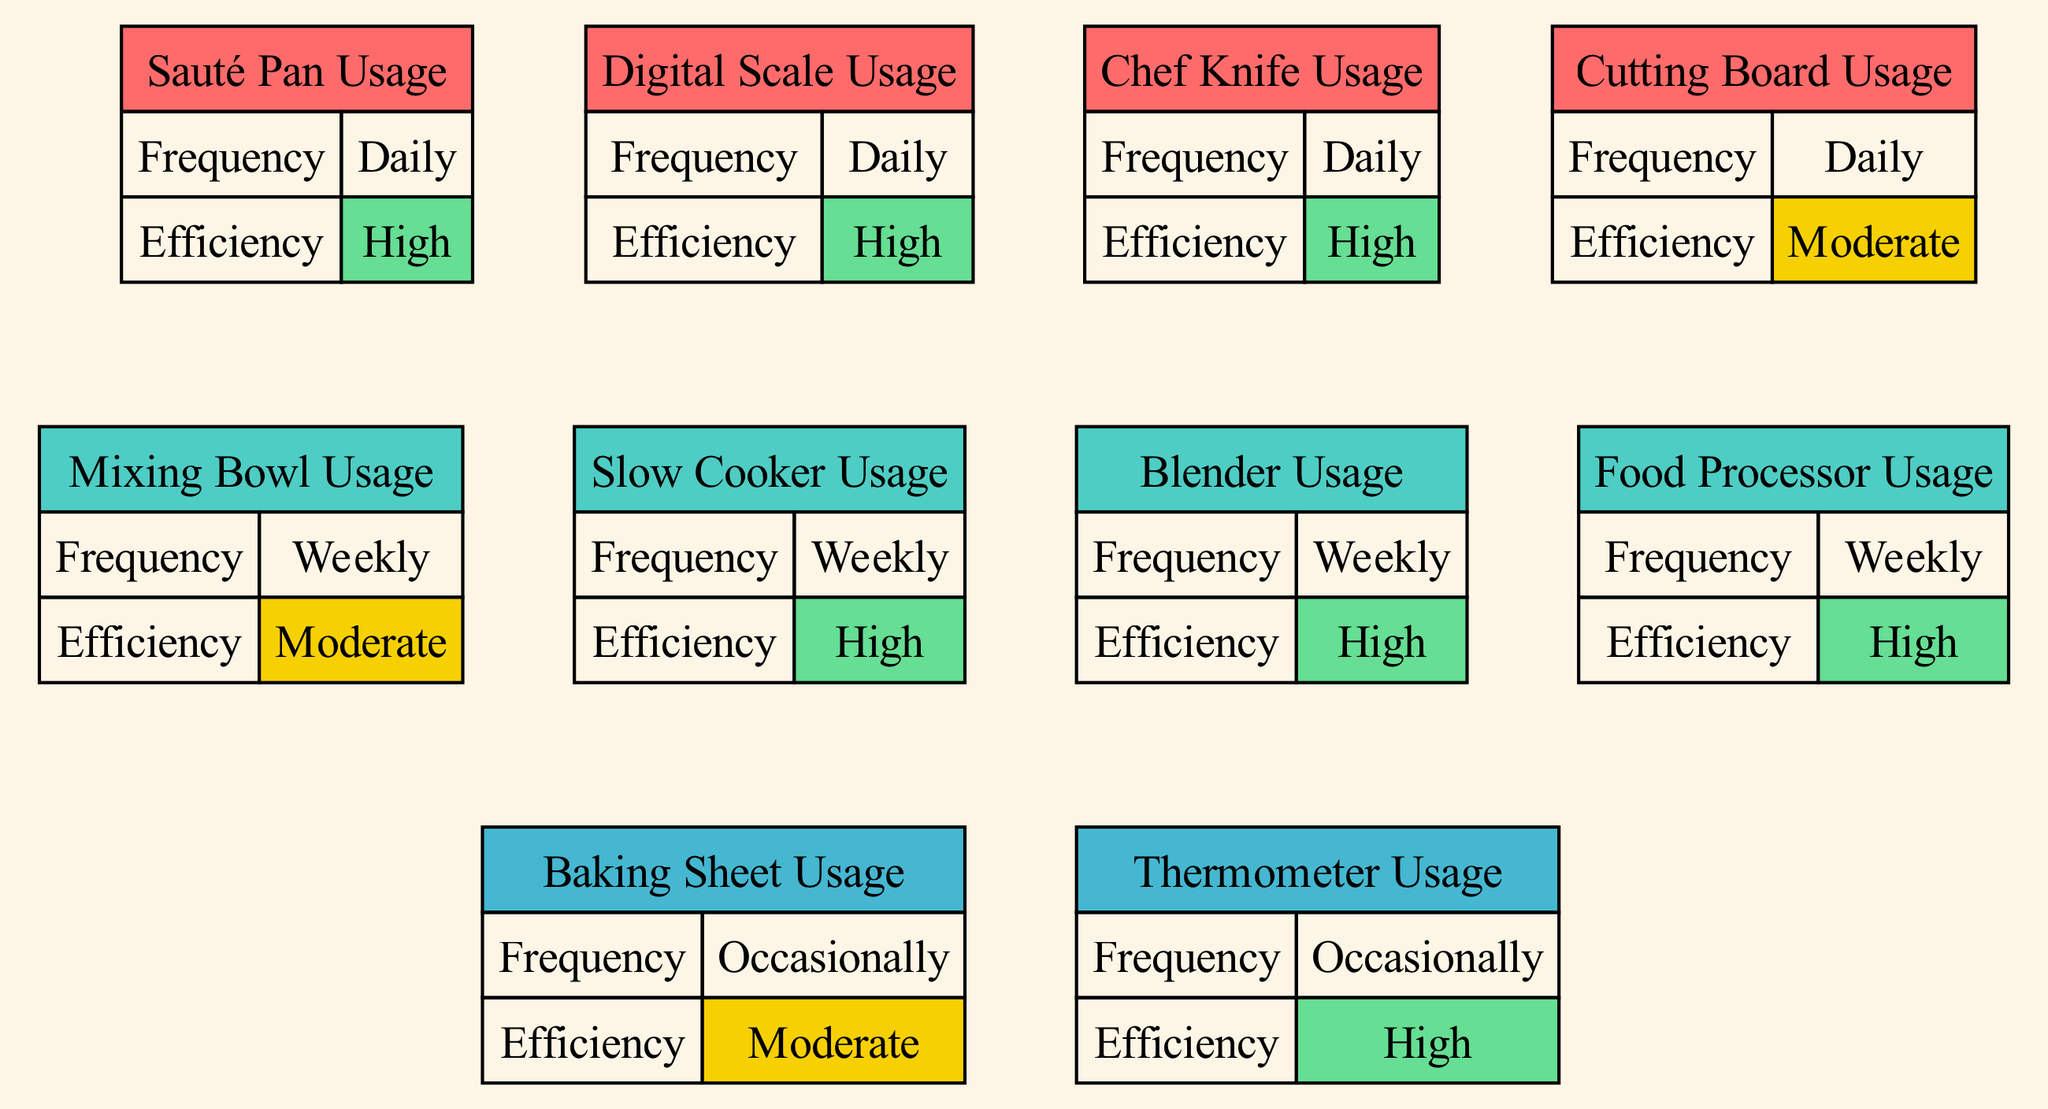What is the frequency of Chef Knife usage? The diagram shows that Chef Knife usage is labeled with the frequency "Daily" in its node information.
Answer: Daily How many kitchen tools are used frequently? By tallying the nodes categorized under "Daily" frequency, it can be seen that there are 5 kitchen tools (Chef Knife, Cutting Board, Sauté Pan, Digital Scale, Thermometer) in this category.
Answer: 5 Which tool has the highest efficiency that is used occasionally? Looking at the nodes, the Thermometer is indicated to have the highest efficiency rating of "High," and is categorized under "Occasionally".
Answer: Thermometer List the frequency of Food Processor usage. The node for Food Processor states that it has a frequency of "Weekly."
Answer: Weekly Which kitchen tool is used both daily and has high efficiency? The nodes show that both the Chef Knife and Sauté Pan are used daily and rated as having high efficiency.
Answer: Chef Knife, Sauté Pan Explain the relationship between the usage frequency of Baking Sheet and its efficiency. The diagram indicates that Baking Sheet usage is "Occasionally" with a "Moderate" efficiency; this highlights that it is not frequently used compared to other tools, and its efficiency is also not rated highly, thus suggesting it is not a primary kitchen tool.
Answer: Occasionally, Moderate How does the frequency of the Blender compare to the Sauté Pan? The Blender is indicated to be used "Weekly," whereas the Sauté Pan is used "Daily," thus Sauté Pan is used more frequently than the Blender.
Answer: Sauté Pan What color represents the efficiency of Digital Scale in the diagram? Referring to the diagram, the Digital Scale node shows a background color that corresponds to "High" efficiency, which is represented as "#66DE93."
Answer: High Identify the tool used occasionally with moderate efficiency. By analyzing the nodes, the Baking Sheet is categorized as being used "Occasionally," and it has a "Moderate" efficiency.
Answer: Baking Sheet 